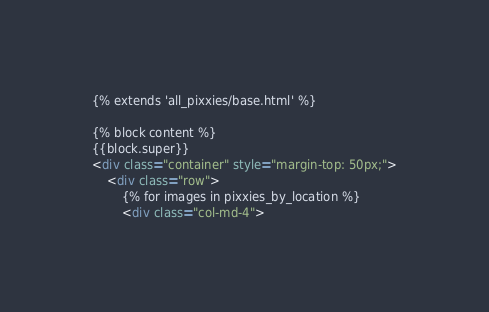<code> <loc_0><loc_0><loc_500><loc_500><_HTML_>{% extends 'all_pixxies/base.html' %}

{% block content %}
{{block.super}}
<div class="container" style="margin-top: 50px;">
    <div class="row">
        {% for images in pixxies_by_location %}
        <div class="col-md-4"></code> 